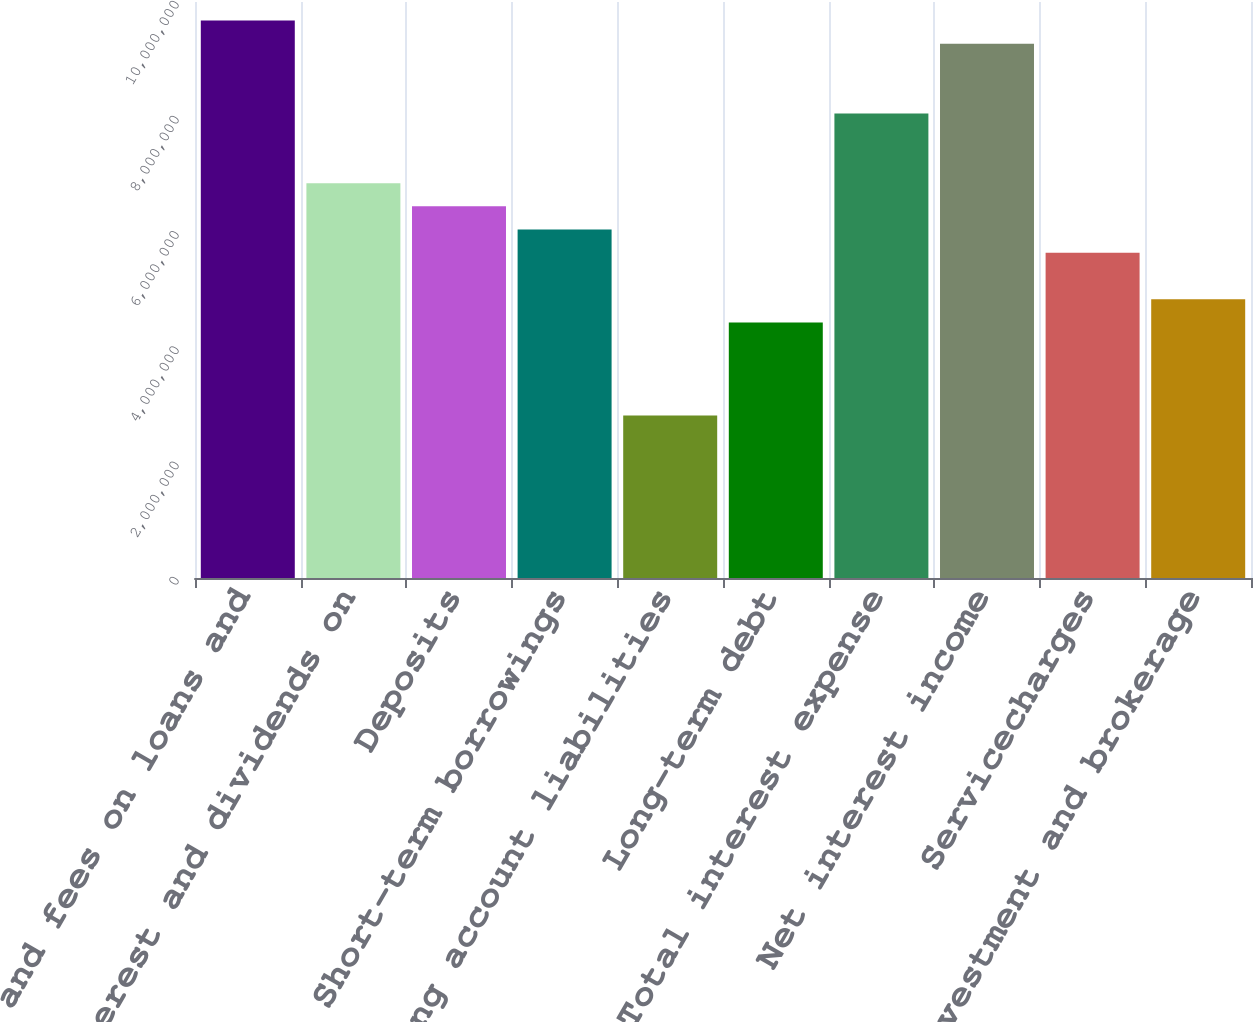<chart> <loc_0><loc_0><loc_500><loc_500><bar_chart><fcel>Interest and fees on loans and<fcel>Interest and dividends on<fcel>Deposits<fcel>Short-term borrowings<fcel>Trading account liabilities<fcel>Long-term debt<fcel>Total interest expense<fcel>Net interest income<fcel>Servicecharges<fcel>Investment and brokerage<nl><fcel>9.67812e+06<fcel>6.85533e+06<fcel>6.45208e+06<fcel>6.04882e+06<fcel>2.82279e+06<fcel>4.4358e+06<fcel>8.0651e+06<fcel>9.27486e+06<fcel>5.64557e+06<fcel>4.83906e+06<nl></chart> 